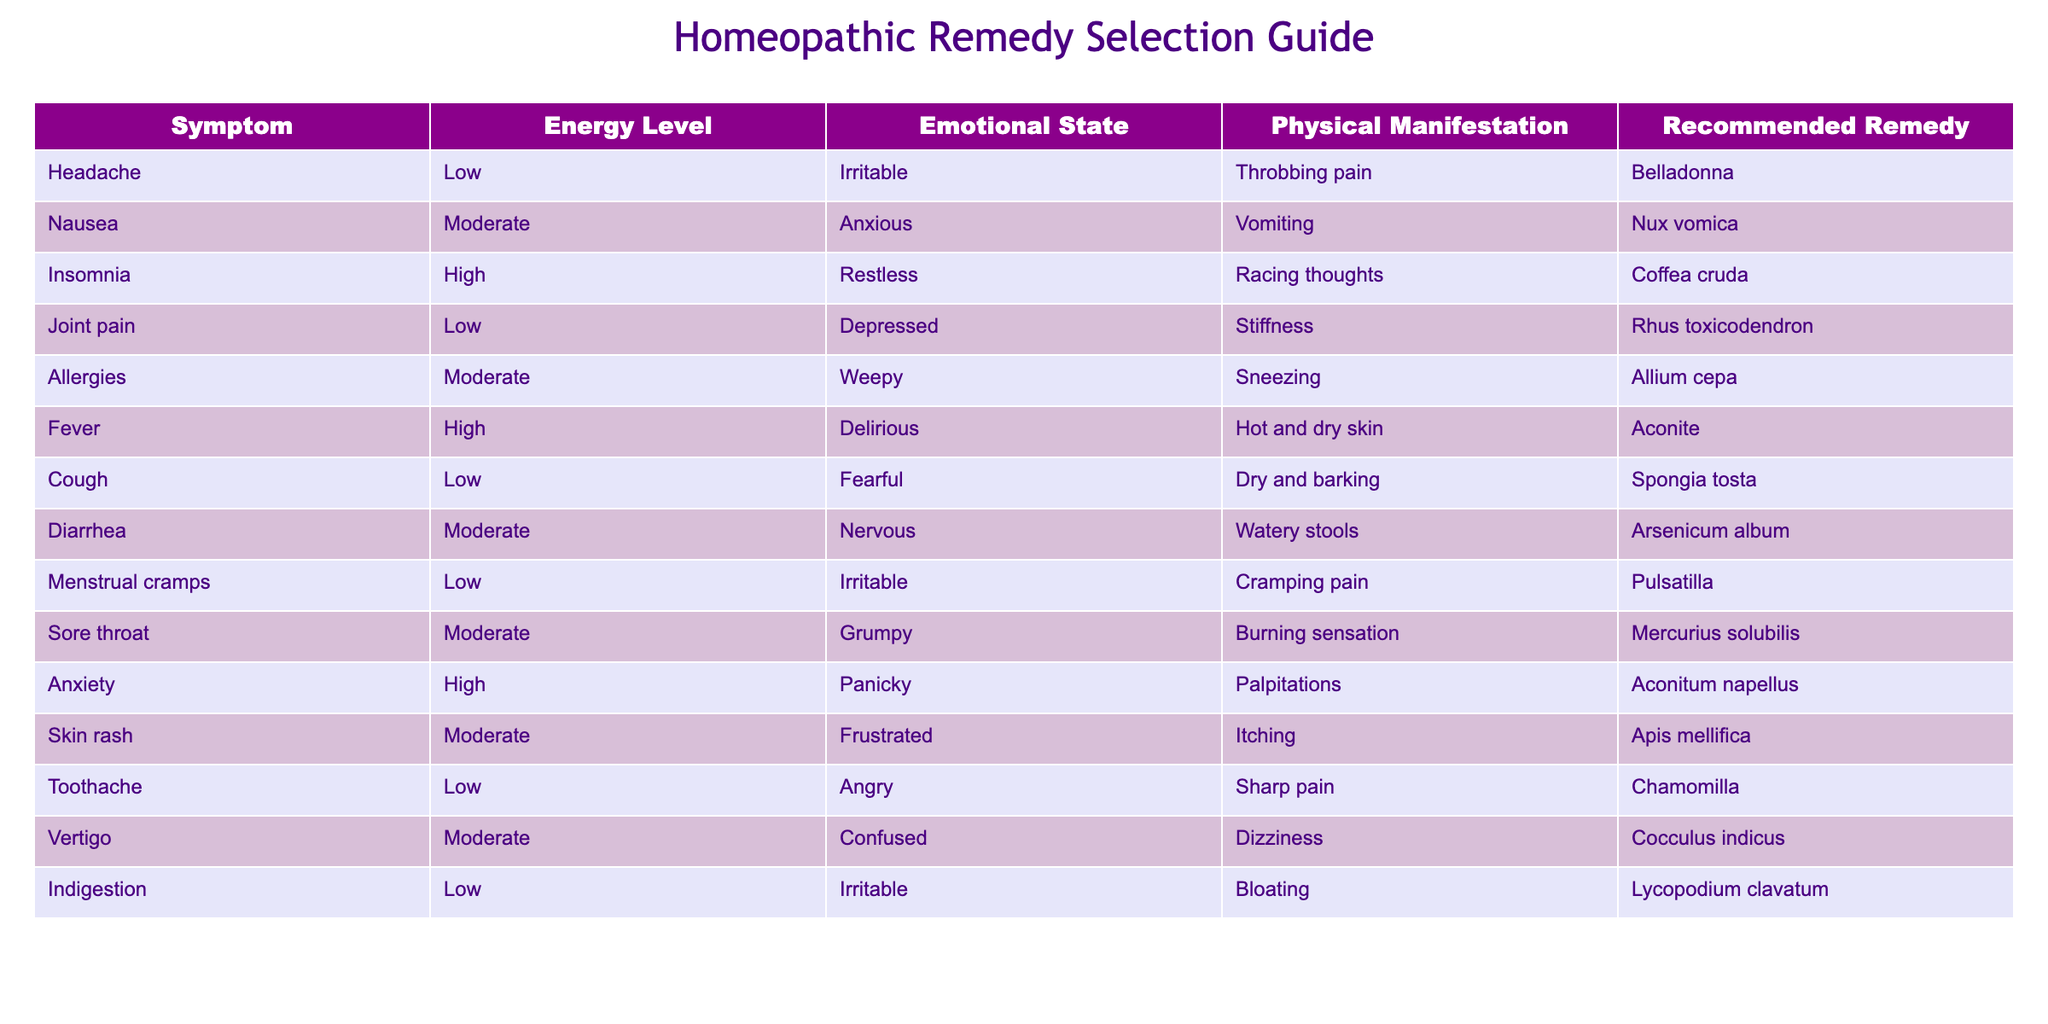What homeopathic remedy is recommended for headaches? The table lists "Headache" under the "Symptom" column, and the corresponding "Recommended Remedy" is "Belladonna."
Answer: Belladonna Which remedy is suggested for joint pain accompanied by a low energy level? "Joint pain" appears in the "Symptom" column, and it corresponds to "Rhus toxicodendron" in the "Recommended Remedy" column.
Answer: Rhus toxicodendron Is "Coffea cruda" recommended for symptoms of restlessness with high energy? The table indicates "Insomnia" has a "High" energy level and corresponds to "Coffea cruda" as the recommended remedy, so the statement is true.
Answer: Yes What is the remedy for nausea and what is the emotional state associated with it? The symptom "Nausea" in the table corresponds with "Anxious" in the "Emotional State" column and the recommended remedy is "Nux vomica."
Answer: Nux vomica; Anxious Which remedy would you recommend for someone experiencing both diarrhea and a moderate emotional state? "Diarrhea" in the table shows a "Moderate" energy level and suggests "Arsenicum album" as the remedy. Thus, for that combination, "Arsenicum album" is the remedy.
Answer: Arsenicum album What is the sum of energy levels for the symptoms that are associated with the remedy "Aconite"? The table shows two symptoms related to "Aconite": "Fever" (High) which indicates a presumed value of 3, and "Anxiety" (High), also presumed as 3. Adding these gives us a total of 3 + 3 = 6.
Answer: 6 Is "Chamomilla" recommended for emotional states of individuals that are angry? The table specifies "Toothache" as the symptom linked with "Chamomilla," which has an emotional state of "Angry." Therefore, the remedy is correctly associated with that emotional state.
Answer: Yes What remedy is indicated for a patient with a sore throat and a grumpy emotional state? The symptom in the table correlates "Sore throat" with the emotional state "Grumpy," and the recommended remedy is "Mercurius solubilis."
Answer: Mercurius solubilis How many symptoms in the table are associated with a high energy level? The table indicates three symptoms with a high energy level: "Insomnia," "Fever," and "Anxiety." The count is thus 3.
Answer: 3 Are there any remedies presented for symptoms related to physical manifestations of dizziness? The table lists "Vertigo," which corresponds to "Dizziness" under the physical manifestation; the remedy "Cocculus indicus" is suggested. So, remedies are present for such symptoms.
Answer: Yes 